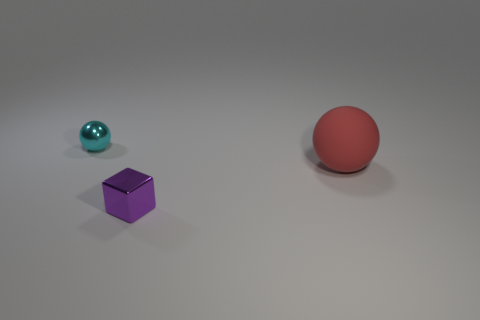There is a thing on the right side of the metal cube; what number of blocks are on the right side of it?
Provide a succinct answer. 0. Are there fewer big spheres that are behind the large red ball than spheres on the right side of the small shiny block?
Offer a very short reply. Yes. There is a small object behind the tiny purple metal cube that is right of the small ball; what shape is it?
Provide a short and direct response. Sphere. What number of other things are there of the same material as the tiny cyan sphere
Provide a short and direct response. 1. Is there any other thing that is the same size as the red rubber thing?
Keep it short and to the point. No. Is the number of blocks greater than the number of spheres?
Your answer should be compact. No. How big is the metallic ball that is to the left of the cube that is on the right side of the tiny metallic thing that is left of the purple metallic object?
Offer a very short reply. Small. Do the cyan object and the object in front of the big red matte object have the same size?
Your response must be concise. Yes. Are there fewer small purple shiny blocks behind the metallic cube than cyan metallic spheres?
Offer a terse response. Yes. Are there fewer red things than large red cylinders?
Your response must be concise. No. 